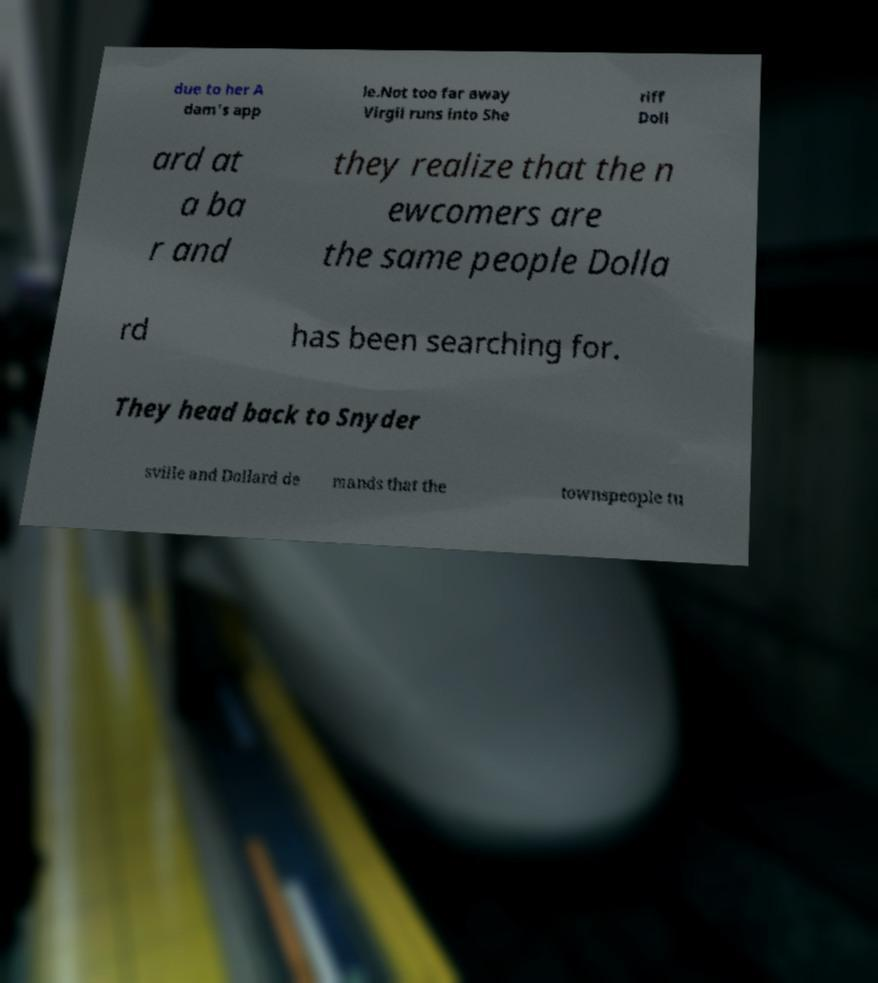Can you accurately transcribe the text from the provided image for me? due to her A dam's app le.Not too far away Virgil runs into She riff Doll ard at a ba r and they realize that the n ewcomers are the same people Dolla rd has been searching for. They head back to Snyder sville and Dollard de mands that the townspeople tu 